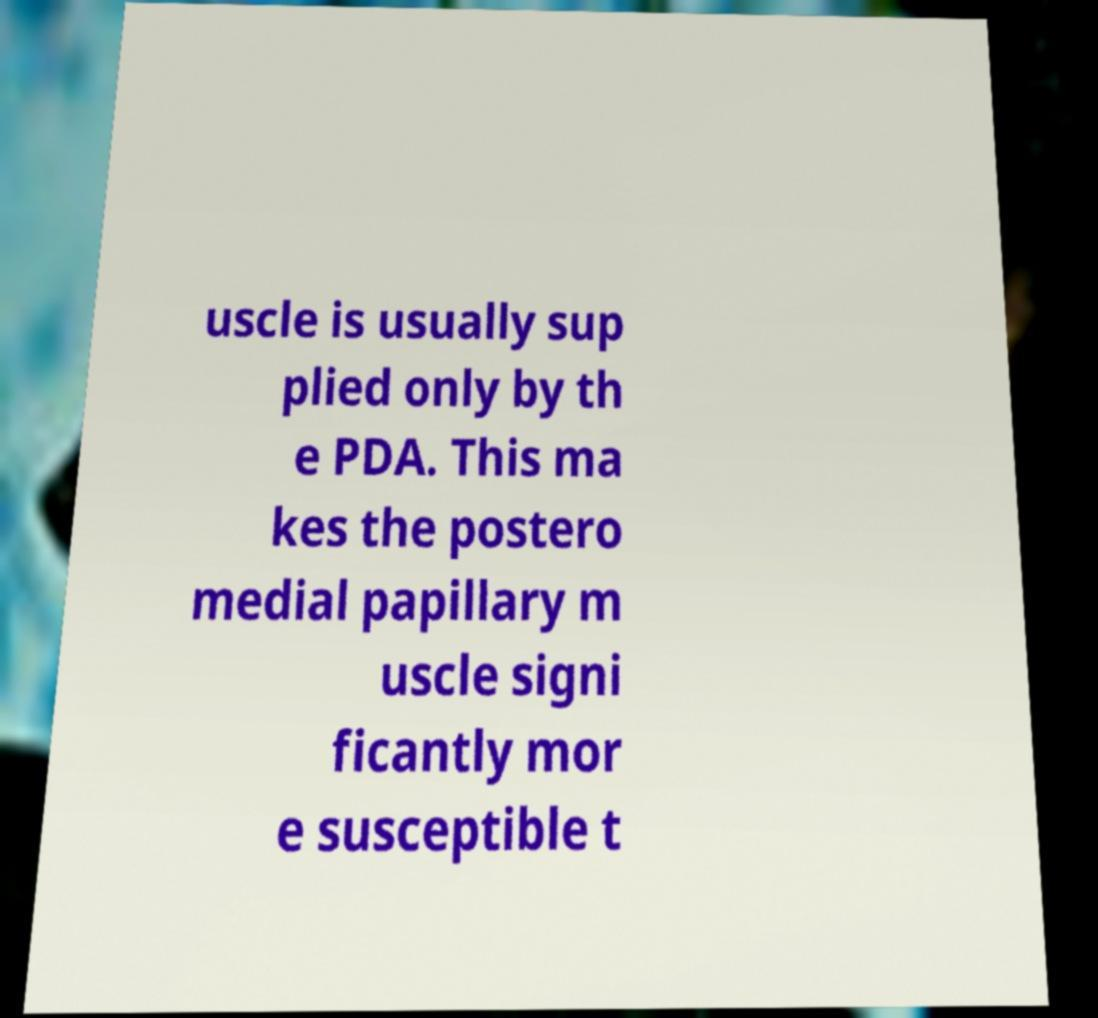Can you read and provide the text displayed in the image?This photo seems to have some interesting text. Can you extract and type it out for me? uscle is usually sup plied only by th e PDA. This ma kes the postero medial papillary m uscle signi ficantly mor e susceptible t 